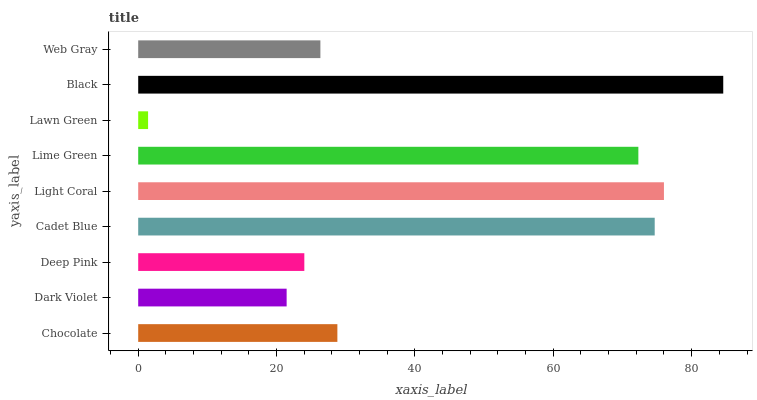Is Lawn Green the minimum?
Answer yes or no. Yes. Is Black the maximum?
Answer yes or no. Yes. Is Dark Violet the minimum?
Answer yes or no. No. Is Dark Violet the maximum?
Answer yes or no. No. Is Chocolate greater than Dark Violet?
Answer yes or no. Yes. Is Dark Violet less than Chocolate?
Answer yes or no. Yes. Is Dark Violet greater than Chocolate?
Answer yes or no. No. Is Chocolate less than Dark Violet?
Answer yes or no. No. Is Chocolate the high median?
Answer yes or no. Yes. Is Chocolate the low median?
Answer yes or no. Yes. Is Deep Pink the high median?
Answer yes or no. No. Is Lawn Green the low median?
Answer yes or no. No. 